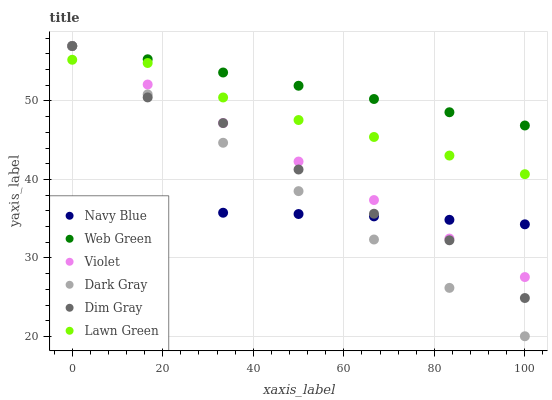Does Navy Blue have the minimum area under the curve?
Answer yes or no. Yes. Does Web Green have the maximum area under the curve?
Answer yes or no. Yes. Does Dim Gray have the minimum area under the curve?
Answer yes or no. No. Does Dim Gray have the maximum area under the curve?
Answer yes or no. No. Is Web Green the smoothest?
Answer yes or no. Yes. Is Dim Gray the roughest?
Answer yes or no. Yes. Is Navy Blue the smoothest?
Answer yes or no. No. Is Navy Blue the roughest?
Answer yes or no. No. Does Dark Gray have the lowest value?
Answer yes or no. Yes. Does Dim Gray have the lowest value?
Answer yes or no. No. Does Violet have the highest value?
Answer yes or no. Yes. Does Navy Blue have the highest value?
Answer yes or no. No. Is Lawn Green less than Web Green?
Answer yes or no. Yes. Is Web Green greater than Navy Blue?
Answer yes or no. Yes. Does Dark Gray intersect Dim Gray?
Answer yes or no. Yes. Is Dark Gray less than Dim Gray?
Answer yes or no. No. Is Dark Gray greater than Dim Gray?
Answer yes or no. No. Does Lawn Green intersect Web Green?
Answer yes or no. No. 